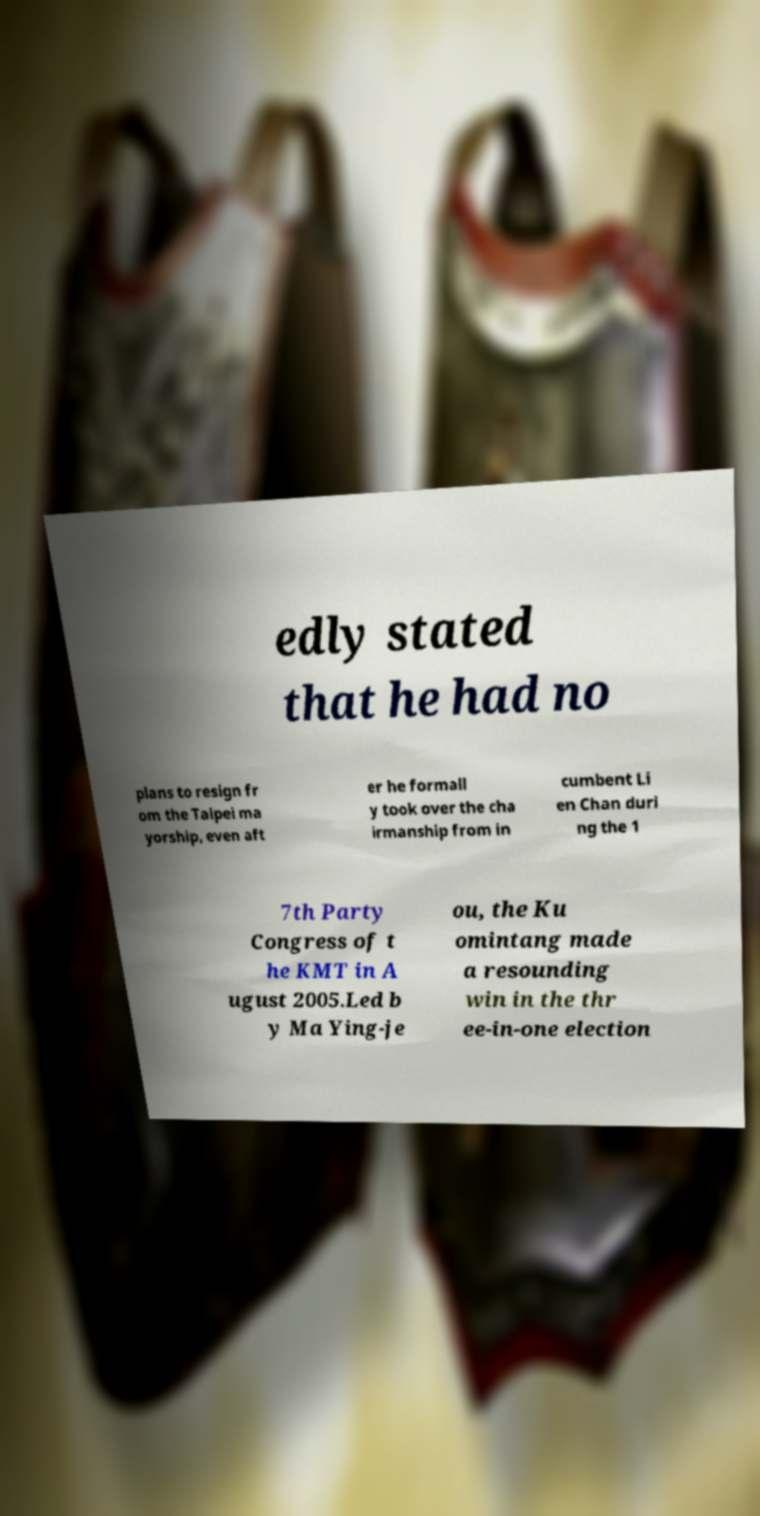I need the written content from this picture converted into text. Can you do that? edly stated that he had no plans to resign fr om the Taipei ma yorship, even aft er he formall y took over the cha irmanship from in cumbent Li en Chan duri ng the 1 7th Party Congress of t he KMT in A ugust 2005.Led b y Ma Ying-je ou, the Ku omintang made a resounding win in the thr ee-in-one election 